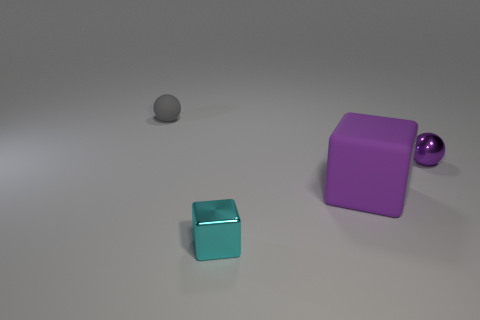Add 1 small cyan metallic cubes. How many objects exist? 5 Subtract all matte blocks. Subtract all large cyan rubber objects. How many objects are left? 3 Add 4 tiny matte balls. How many tiny matte balls are left? 5 Add 3 small gray shiny spheres. How many small gray shiny spheres exist? 3 Subtract 0 green blocks. How many objects are left? 4 